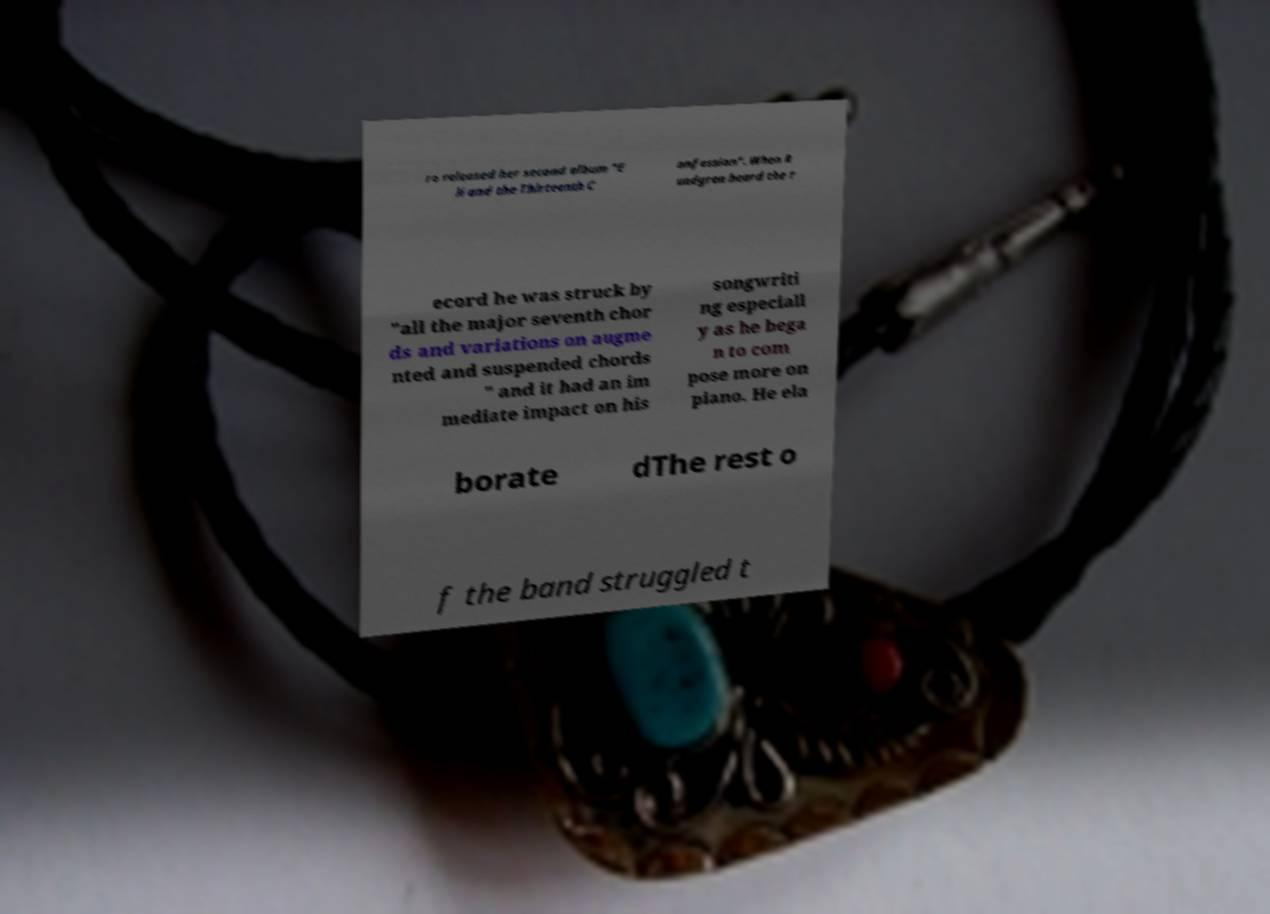For documentation purposes, I need the text within this image transcribed. Could you provide that? ro released her second album "E li and the Thirteenth C onfession". When R undgren heard the r ecord he was struck by "all the major seventh chor ds and variations on augme nted and suspended chords " and it had an im mediate impact on his songwriti ng especiall y as he bega n to com pose more on piano. He ela borate dThe rest o f the band struggled t 